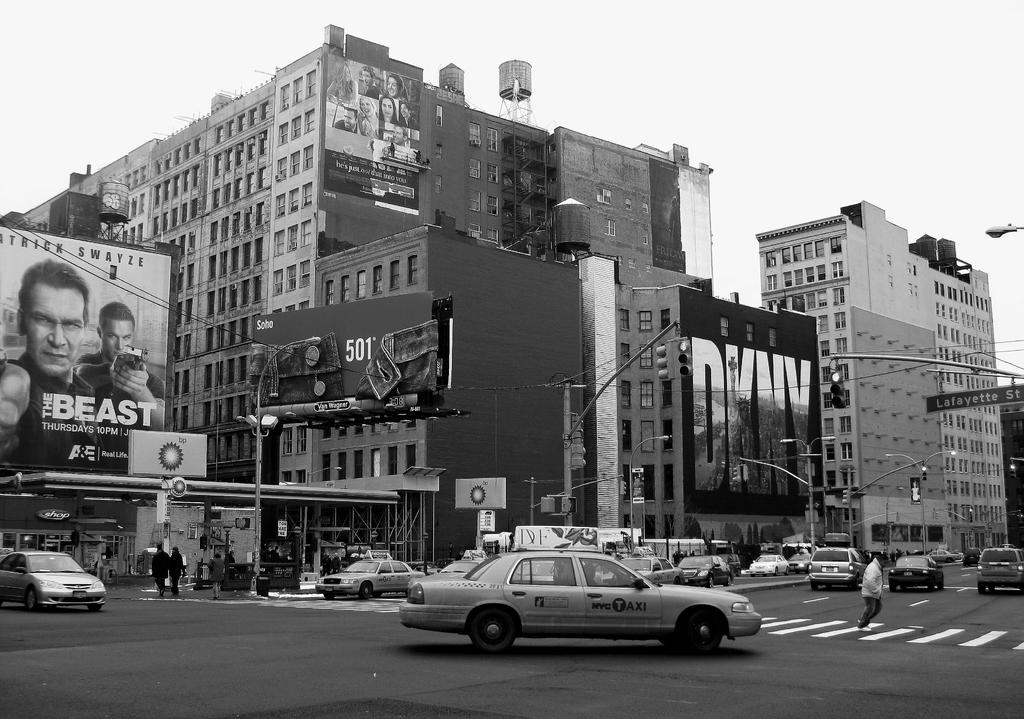<image>
Offer a succinct explanation of the picture presented. A billboard is on the left hand side and advertises a show called The Beast. 